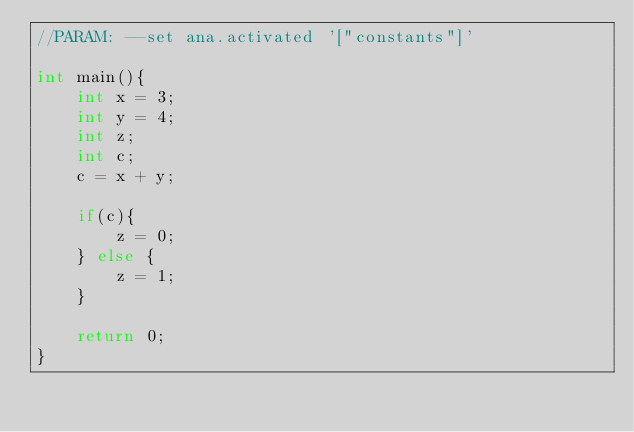<code> <loc_0><loc_0><loc_500><loc_500><_C_>//PARAM: --set ana.activated '["constants"]'

int main(){
    int x = 3;
    int y = 4;
    int z;
    int c;
    c = x + y;

    if(c){
        z = 0;
    } else {
        z = 1;
    }

    return 0;
}
</code> 